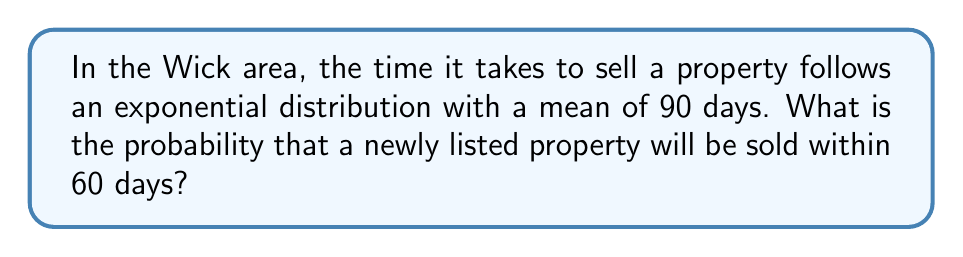Provide a solution to this math problem. To solve this problem, we need to use the properties of the exponential distribution:

1. The exponential distribution is characterized by its rate parameter $\lambda$, which is the inverse of the mean.

2. Given:
   - Mean time to sell = 90 days
   - We want to find P(X ≤ 60), where X is the time to sell

3. Calculate $\lambda$:
   $\lambda = \frac{1}{\text{mean}} = \frac{1}{90} \approx 0.0111$ per day

4. The cumulative distribution function (CDF) of an exponential distribution is:
   $F(x) = 1 - e^{-\lambda x}$

5. We want to find P(X ≤ 60):
   $P(X \leq 60) = F(60) = 1 - e^{-\lambda \cdot 60}$

6. Substitute the values:
   $P(X \leq 60) = 1 - e^{-0.0111 \cdot 60}$

7. Calculate:
   $P(X \leq 60) = 1 - e^{-0.666} \approx 0.4861$

Therefore, the probability of selling a property within 60 days is approximately 0.4861 or 48.61%.
Answer: $P(X \leq 60) \approx 0.4861$ or 48.61% 